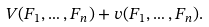<formula> <loc_0><loc_0><loc_500><loc_500>V ( F _ { 1 } , \dots , F _ { n } ) + v ( F _ { 1 } , \dots , F _ { n } ) .</formula> 